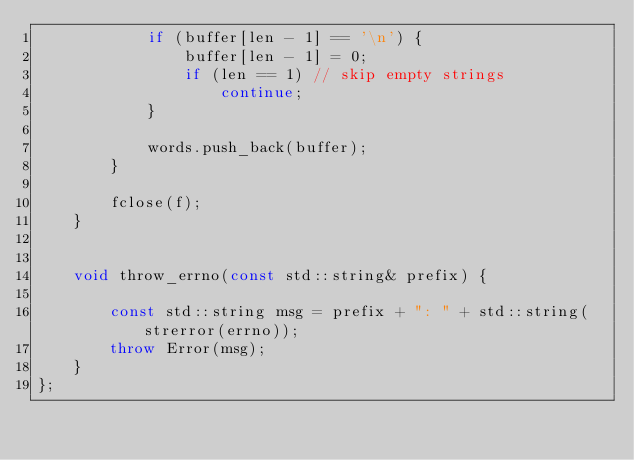Convert code to text. <code><loc_0><loc_0><loc_500><loc_500><_C++_>            if (buffer[len - 1] == '\n') {
                buffer[len - 1] = 0;
                if (len == 1) // skip empty strings
                    continue;
            }

            words.push_back(buffer);
        }

        fclose(f);
    }


    void throw_errno(const std::string& prefix) {

        const std::string msg = prefix + ": " + std::string(strerror(errno));
        throw Error(msg);
    }
};

</code> 